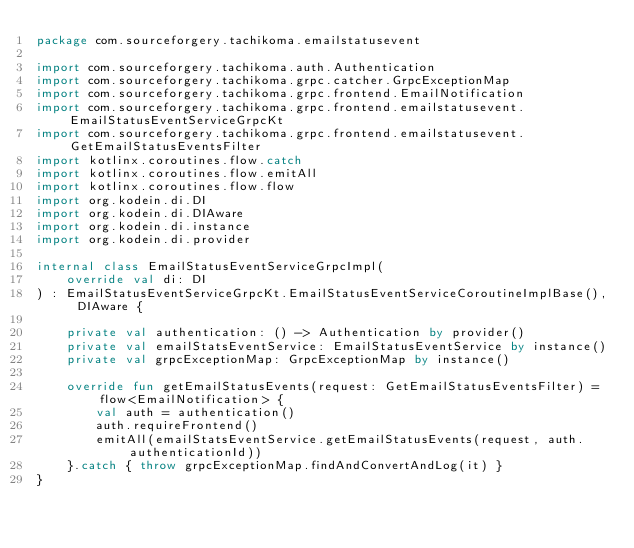<code> <loc_0><loc_0><loc_500><loc_500><_Kotlin_>package com.sourceforgery.tachikoma.emailstatusevent

import com.sourceforgery.tachikoma.auth.Authentication
import com.sourceforgery.tachikoma.grpc.catcher.GrpcExceptionMap
import com.sourceforgery.tachikoma.grpc.frontend.EmailNotification
import com.sourceforgery.tachikoma.grpc.frontend.emailstatusevent.EmailStatusEventServiceGrpcKt
import com.sourceforgery.tachikoma.grpc.frontend.emailstatusevent.GetEmailStatusEventsFilter
import kotlinx.coroutines.flow.catch
import kotlinx.coroutines.flow.emitAll
import kotlinx.coroutines.flow.flow
import org.kodein.di.DI
import org.kodein.di.DIAware
import org.kodein.di.instance
import org.kodein.di.provider

internal class EmailStatusEventServiceGrpcImpl(
    override val di: DI
) : EmailStatusEventServiceGrpcKt.EmailStatusEventServiceCoroutineImplBase(), DIAware {

    private val authentication: () -> Authentication by provider()
    private val emailStatsEventService: EmailStatusEventService by instance()
    private val grpcExceptionMap: GrpcExceptionMap by instance()

    override fun getEmailStatusEvents(request: GetEmailStatusEventsFilter) = flow<EmailNotification> {
        val auth = authentication()
        auth.requireFrontend()
        emitAll(emailStatsEventService.getEmailStatusEvents(request, auth.authenticationId))
    }.catch { throw grpcExceptionMap.findAndConvertAndLog(it) }
}
</code> 